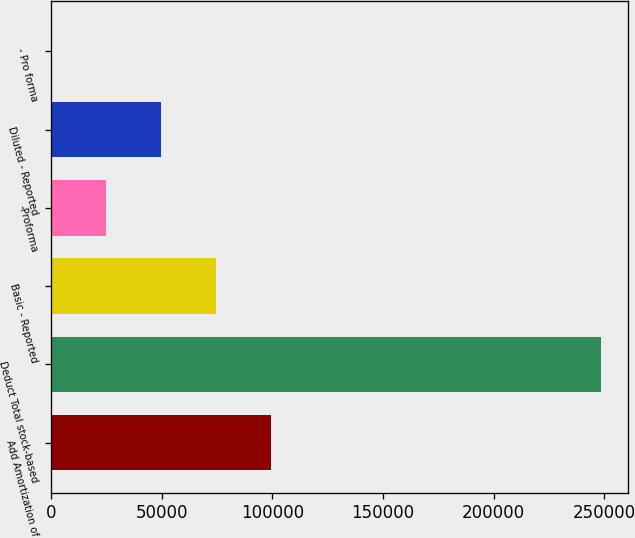<chart> <loc_0><loc_0><loc_500><loc_500><bar_chart><fcel>Add Amortization of<fcel>Deduct Total stock-based<fcel>Basic - Reported<fcel>-Proforma<fcel>Diluted - Reported<fcel>- Pro forma<nl><fcel>99304.4<fcel>248260<fcel>74478.4<fcel>24826.5<fcel>49652.5<fcel>0.61<nl></chart> 